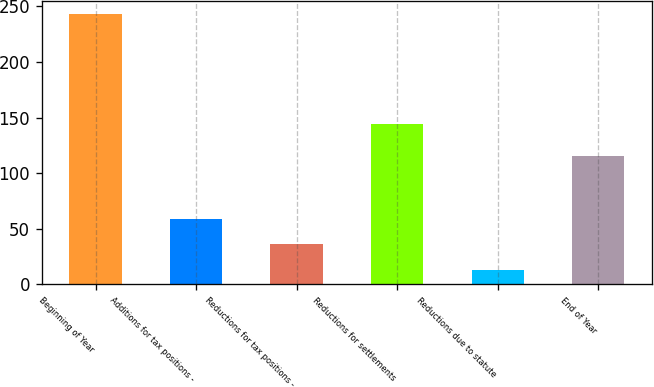Convert chart. <chart><loc_0><loc_0><loc_500><loc_500><bar_chart><fcel>Beginning of Year<fcel>Additions for tax positions -<fcel>Reductions for tax positions -<fcel>Reductions for settlements<fcel>Reductions due to statute<fcel>End of Year<nl><fcel>243<fcel>59<fcel>36<fcel>144<fcel>13<fcel>115<nl></chart> 